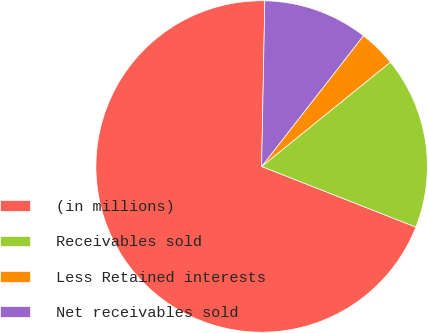Convert chart to OTSL. <chart><loc_0><loc_0><loc_500><loc_500><pie_chart><fcel>(in millions)<fcel>Receivables sold<fcel>Less Retained interests<fcel>Net receivables sold<nl><fcel>69.35%<fcel>16.79%<fcel>3.64%<fcel>10.22%<nl></chart> 